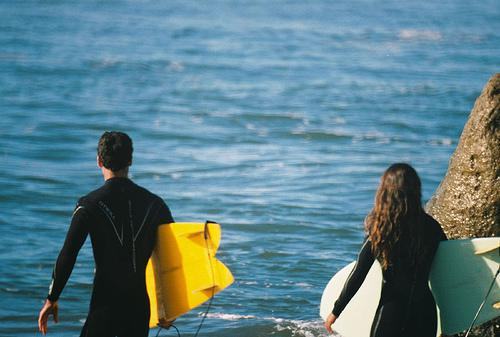Question: what color are the people's wetsuits?
Choices:
A. Black.
B. Blue.
C. Yellow.
D. Red.
Answer with the letter. Answer: A Question: how many people?
Choices:
A. 1.
B. 3.
C. 2.
D. 4.
Answer with the letter. Answer: C Question: what are the people looking at?
Choices:
A. Water.
B. Animals.
C. Flowers.
D. Trees.
Answer with the letter. Answer: A Question: who has the white surfboard?
Choices:
A. The man.
B. The girl.
C. The boy.
D. The woman.
Answer with the letter. Answer: D Question: what color is the water?
Choices:
A. Blue.
B. Red.
C. Green.
D. Brown.
Answer with the letter. Answer: A Question: who has the yellow surfboard?
Choices:
A. The woman.
B. The man.
C. The boy.
D. The girl.
Answer with the letter. Answer: B 